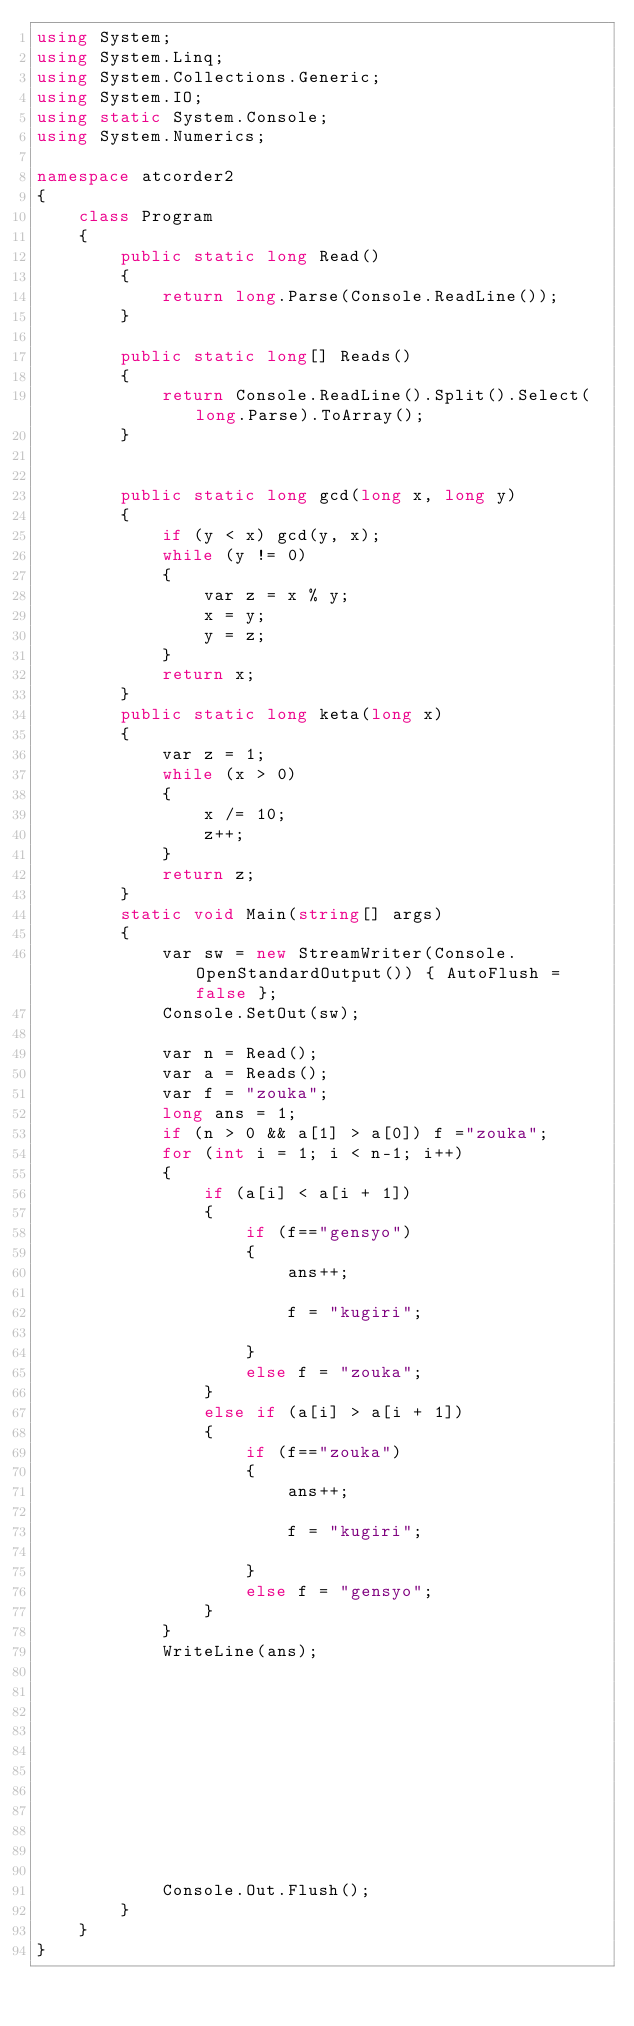<code> <loc_0><loc_0><loc_500><loc_500><_C#_>using System;
using System.Linq;
using System.Collections.Generic;
using System.IO;
using static System.Console;
using System.Numerics;

namespace atcorder2
{
    class Program
    {
        public static long Read()
        {
            return long.Parse(Console.ReadLine());
        }

        public static long[] Reads()
        {
            return Console.ReadLine().Split().Select(long.Parse).ToArray();
        }


        public static long gcd(long x, long y)
        {
            if (y < x) gcd(y, x);
            while (y != 0)
            {
                var z = x % y;
                x = y;
                y = z;
            }
            return x;
        }
        public static long keta(long x)
        {
            var z = 1;
            while (x > 0)
            {
                x /= 10;
                z++;
            }
            return z;
        }
        static void Main(string[] args)
        {
            var sw = new StreamWriter(Console.OpenStandardOutput()) { AutoFlush = false };
            Console.SetOut(sw);

            var n = Read();
            var a = Reads();
            var f = "zouka";
            long ans = 1;
            if (n > 0 && a[1] > a[0]) f ="zouka";
            for (int i = 1; i < n-1; i++)
            {
                if (a[i] < a[i + 1])
                {
                    if (f=="gensyo")
                    {
                        ans++;
                  
                        f = "kugiri";
                        
                    }
                    else f = "zouka";
                }
                else if (a[i] > a[i + 1])
                {
                    if (f=="zouka")
                    {
                        ans++;
          
                        f = "kugiri";
                      
                    }
                    else f = "gensyo";
                }
            }
            WriteLine(ans);










          
            Console.Out.Flush();
        }
    }
}

</code> 